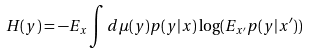<formula> <loc_0><loc_0><loc_500><loc_500>H ( y ) = - E _ { x } \int d \mu ( y ) p ( y | x ) \log ( E _ { x ^ { \prime } } p ( y | x ^ { \prime } ) )</formula> 